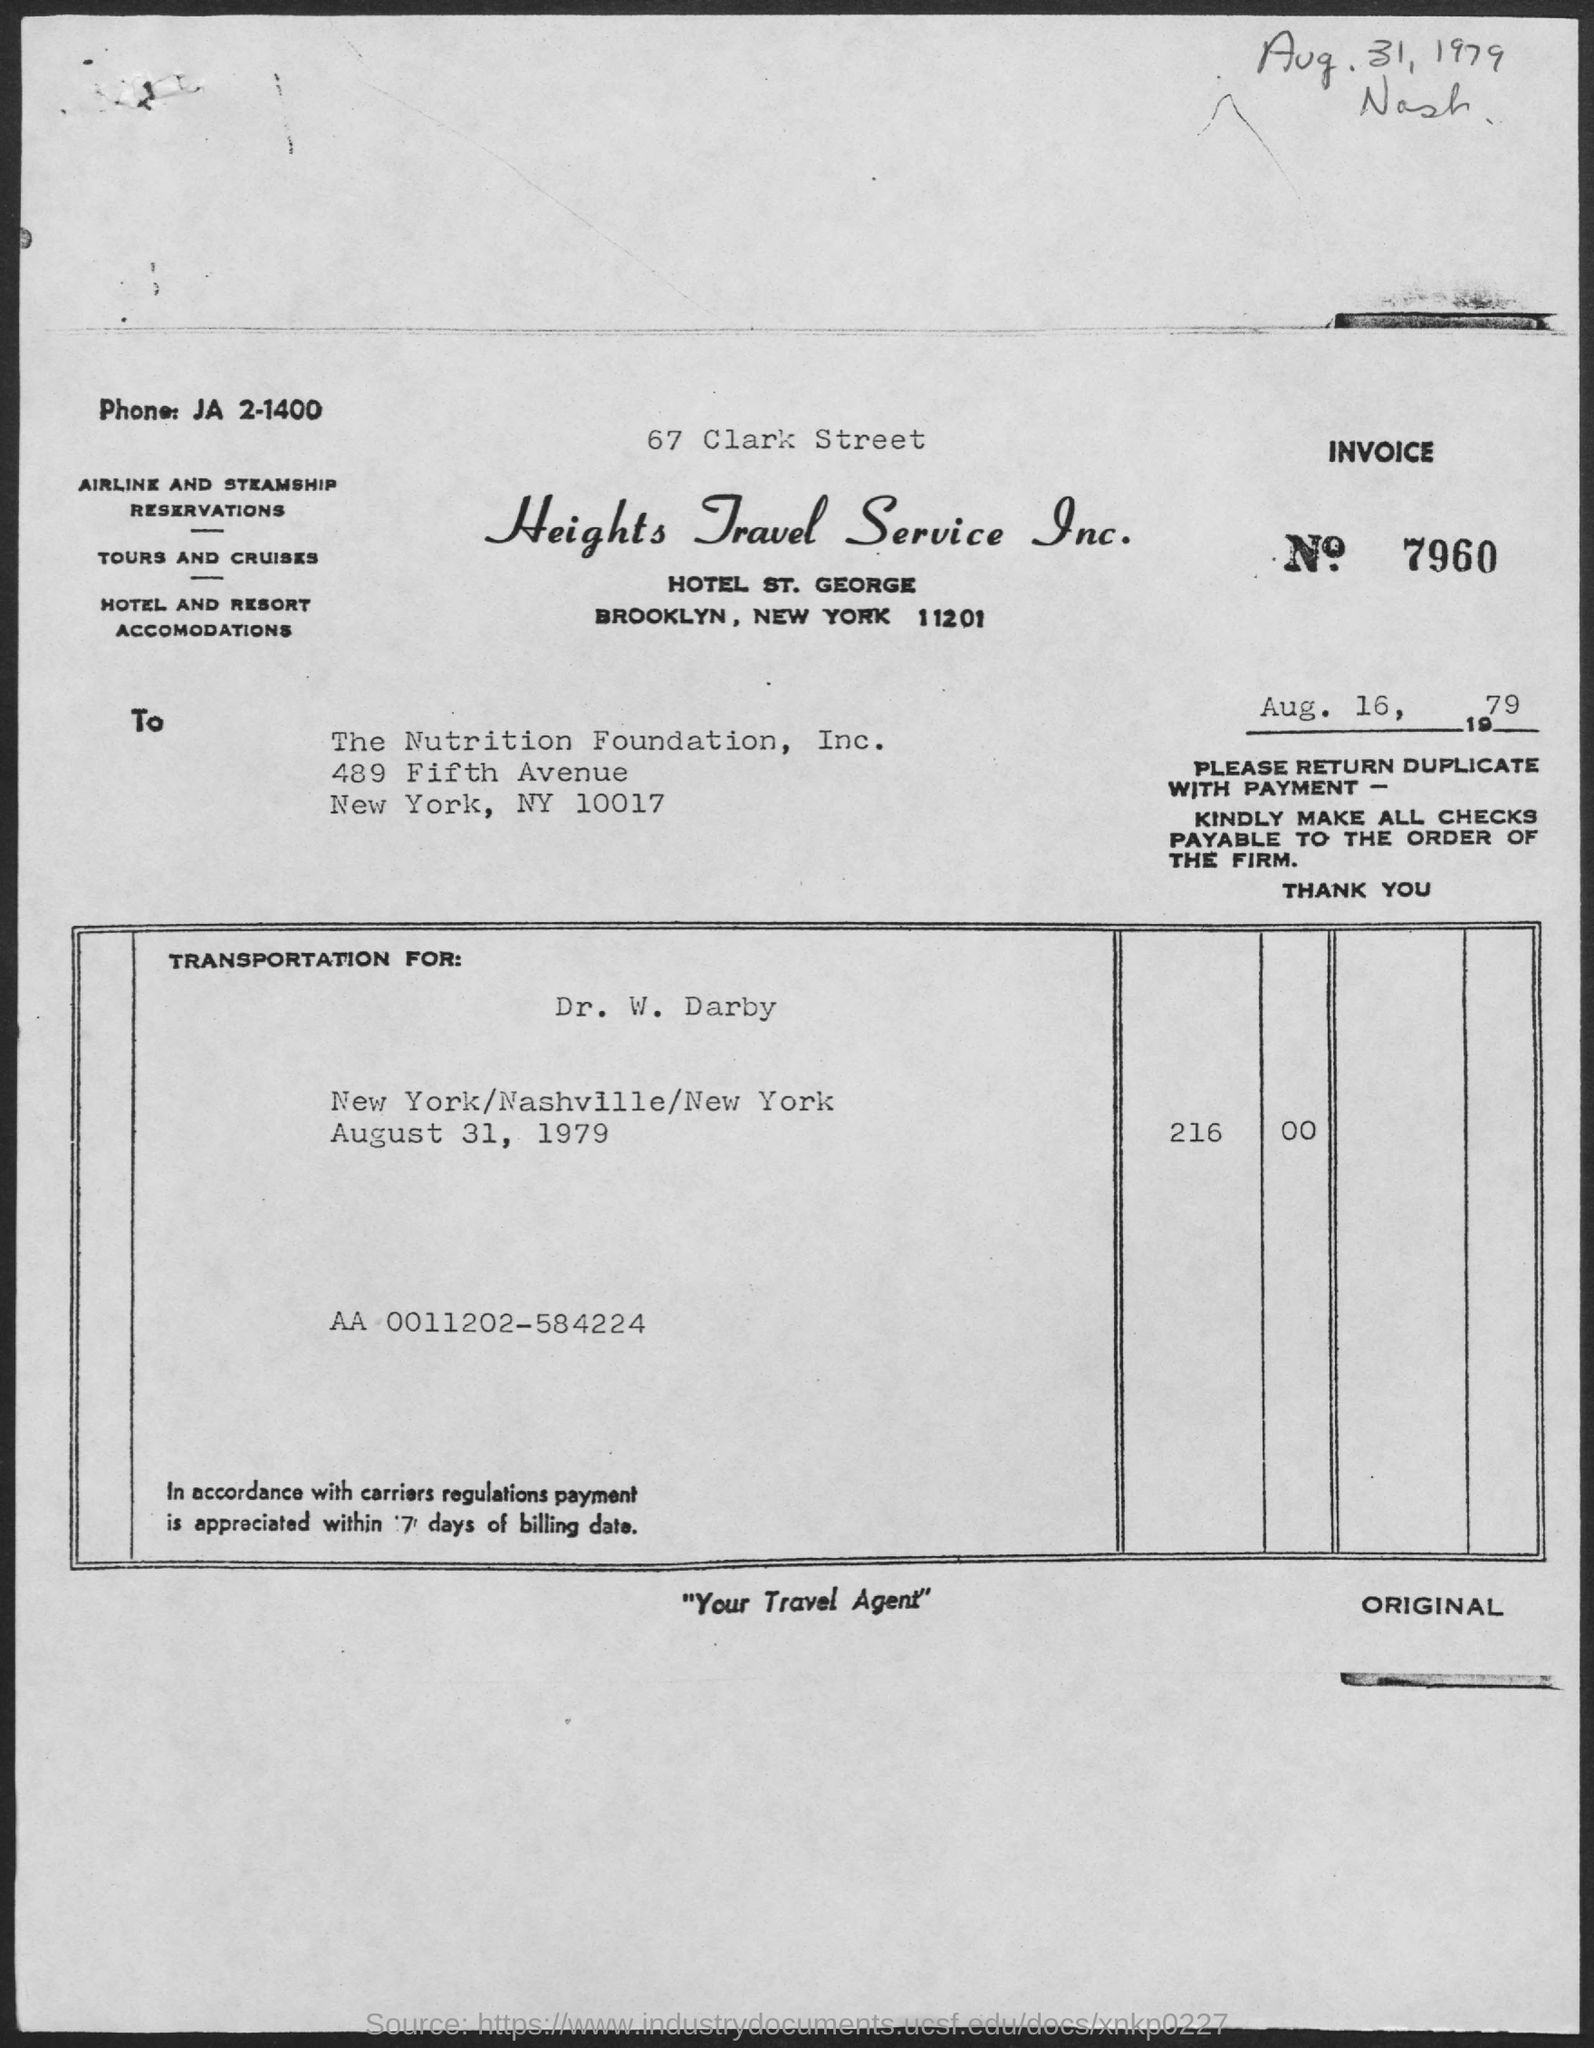What is the Phone Number ?
Give a very brief answer. Ja 2-1400. What is the INVOICE number ?
Your response must be concise. 7960. Who is the Memorandum Addressed to ?
Keep it short and to the point. The nutrition foundation. What is the company name ?
Ensure brevity in your answer.  Heights travel service. 